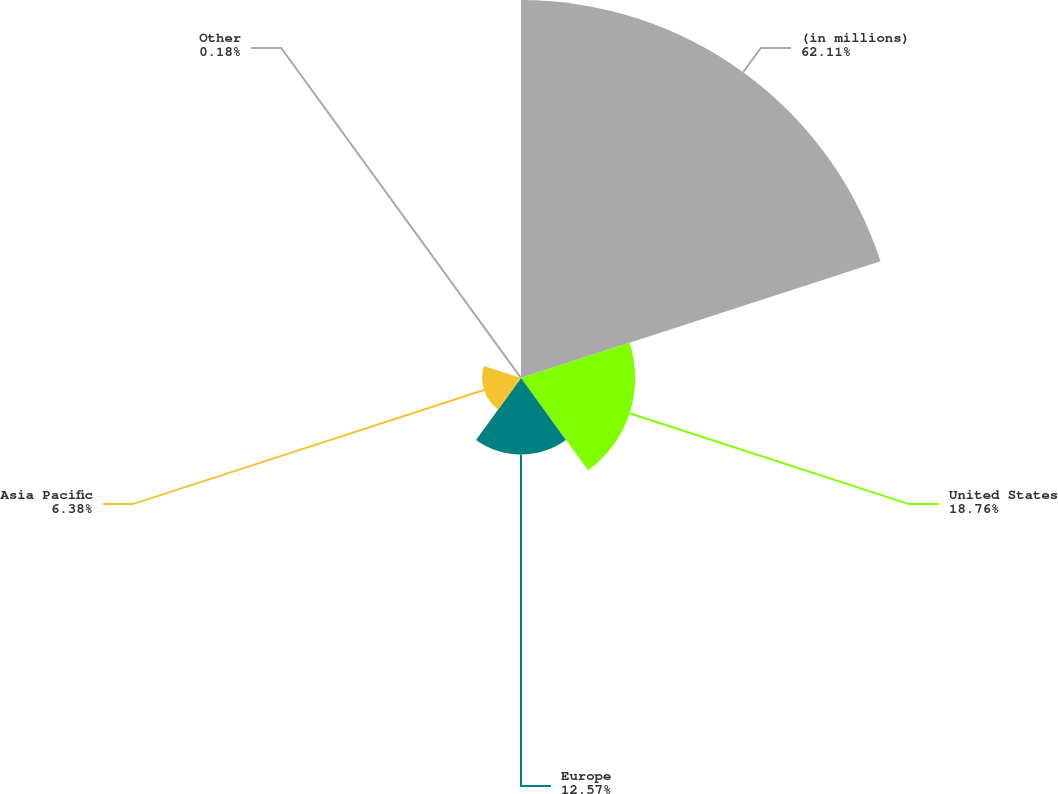Convert chart. <chart><loc_0><loc_0><loc_500><loc_500><pie_chart><fcel>(in millions)<fcel>United States<fcel>Europe<fcel>Asia Pacific<fcel>Other<nl><fcel>62.11%<fcel>18.76%<fcel>12.57%<fcel>6.38%<fcel>0.18%<nl></chart> 